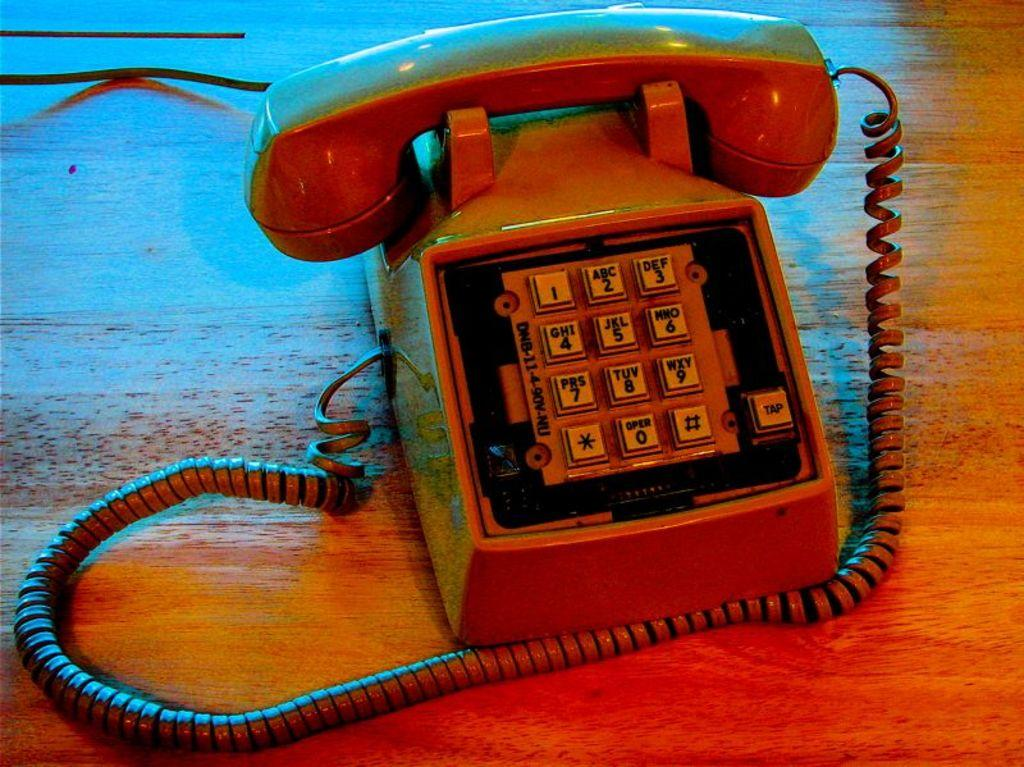What object can be seen in the image? There is a telephone in the image. What is the telephone placed on? The telephone is on a wooden surface. How many worms can be seen crawling on the telephone in the image? There are no worms present in the image; it only features a telephone on a wooden surface. 